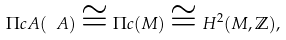Convert formula to latex. <formula><loc_0><loc_0><loc_500><loc_500>\Pi c A ( \ A ) \cong \Pi c ( M ) \cong H ^ { 2 } ( M , \mathbb { Z } ) ,</formula> 